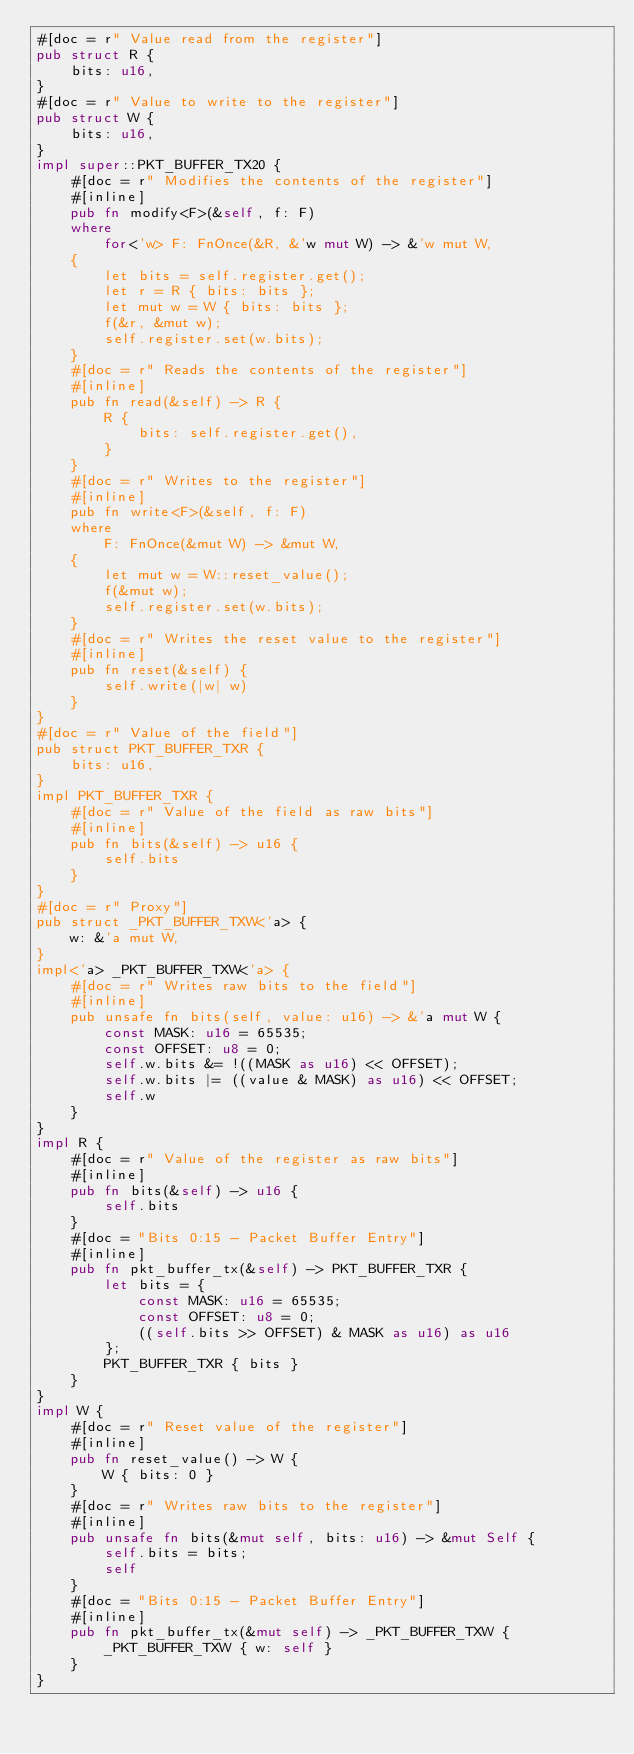Convert code to text. <code><loc_0><loc_0><loc_500><loc_500><_Rust_>#[doc = r" Value read from the register"]
pub struct R {
    bits: u16,
}
#[doc = r" Value to write to the register"]
pub struct W {
    bits: u16,
}
impl super::PKT_BUFFER_TX20 {
    #[doc = r" Modifies the contents of the register"]
    #[inline]
    pub fn modify<F>(&self, f: F)
    where
        for<'w> F: FnOnce(&R, &'w mut W) -> &'w mut W,
    {
        let bits = self.register.get();
        let r = R { bits: bits };
        let mut w = W { bits: bits };
        f(&r, &mut w);
        self.register.set(w.bits);
    }
    #[doc = r" Reads the contents of the register"]
    #[inline]
    pub fn read(&self) -> R {
        R {
            bits: self.register.get(),
        }
    }
    #[doc = r" Writes to the register"]
    #[inline]
    pub fn write<F>(&self, f: F)
    where
        F: FnOnce(&mut W) -> &mut W,
    {
        let mut w = W::reset_value();
        f(&mut w);
        self.register.set(w.bits);
    }
    #[doc = r" Writes the reset value to the register"]
    #[inline]
    pub fn reset(&self) {
        self.write(|w| w)
    }
}
#[doc = r" Value of the field"]
pub struct PKT_BUFFER_TXR {
    bits: u16,
}
impl PKT_BUFFER_TXR {
    #[doc = r" Value of the field as raw bits"]
    #[inline]
    pub fn bits(&self) -> u16 {
        self.bits
    }
}
#[doc = r" Proxy"]
pub struct _PKT_BUFFER_TXW<'a> {
    w: &'a mut W,
}
impl<'a> _PKT_BUFFER_TXW<'a> {
    #[doc = r" Writes raw bits to the field"]
    #[inline]
    pub unsafe fn bits(self, value: u16) -> &'a mut W {
        const MASK: u16 = 65535;
        const OFFSET: u8 = 0;
        self.w.bits &= !((MASK as u16) << OFFSET);
        self.w.bits |= ((value & MASK) as u16) << OFFSET;
        self.w
    }
}
impl R {
    #[doc = r" Value of the register as raw bits"]
    #[inline]
    pub fn bits(&self) -> u16 {
        self.bits
    }
    #[doc = "Bits 0:15 - Packet Buffer Entry"]
    #[inline]
    pub fn pkt_buffer_tx(&self) -> PKT_BUFFER_TXR {
        let bits = {
            const MASK: u16 = 65535;
            const OFFSET: u8 = 0;
            ((self.bits >> OFFSET) & MASK as u16) as u16
        };
        PKT_BUFFER_TXR { bits }
    }
}
impl W {
    #[doc = r" Reset value of the register"]
    #[inline]
    pub fn reset_value() -> W {
        W { bits: 0 }
    }
    #[doc = r" Writes raw bits to the register"]
    #[inline]
    pub unsafe fn bits(&mut self, bits: u16) -> &mut Self {
        self.bits = bits;
        self
    }
    #[doc = "Bits 0:15 - Packet Buffer Entry"]
    #[inline]
    pub fn pkt_buffer_tx(&mut self) -> _PKT_BUFFER_TXW {
        _PKT_BUFFER_TXW { w: self }
    }
}
</code> 